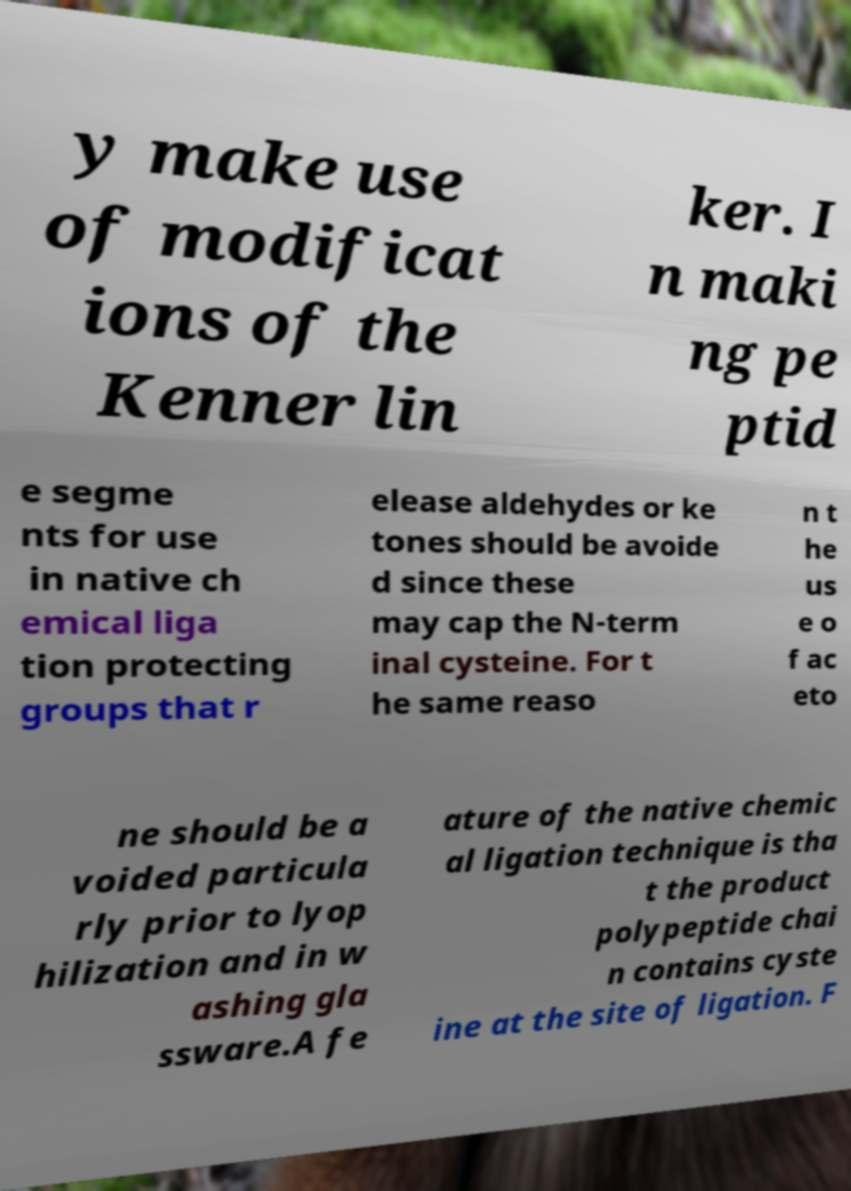Please identify and transcribe the text found in this image. y make use of modificat ions of the Kenner lin ker. I n maki ng pe ptid e segme nts for use in native ch emical liga tion protecting groups that r elease aldehydes or ke tones should be avoide d since these may cap the N-term inal cysteine. For t he same reaso n t he us e o f ac eto ne should be a voided particula rly prior to lyop hilization and in w ashing gla ssware.A fe ature of the native chemic al ligation technique is tha t the product polypeptide chai n contains cyste ine at the site of ligation. F 